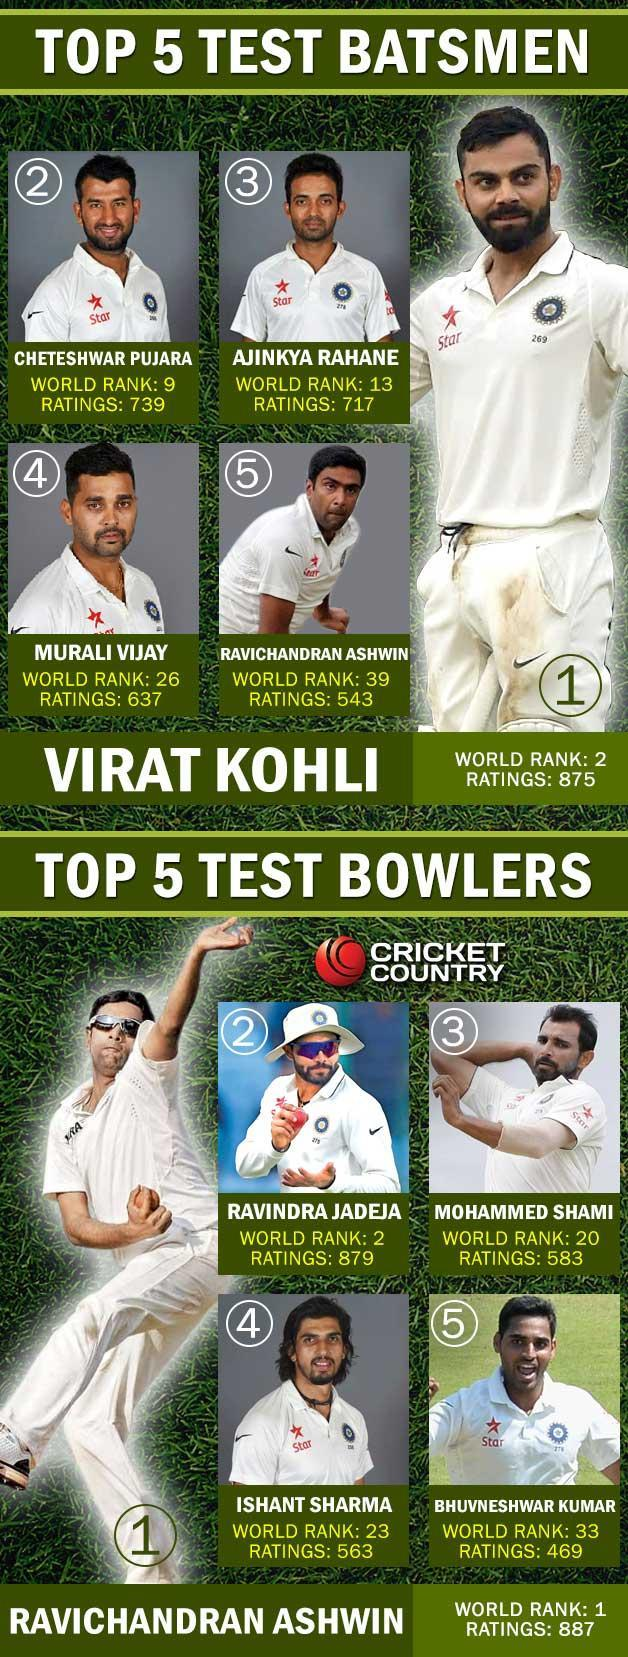Who has the highest world rank in batting-Ravichandran Ashwin or Murali Vijay?
Answer the question with a short phrase. Murali Vijay Who has the highest world rank in bowling-Ishant Sharma or Ravindra Jadeja? Ravindra Jadeja 